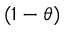<formula> <loc_0><loc_0><loc_500><loc_500>( 1 - \theta )</formula> 